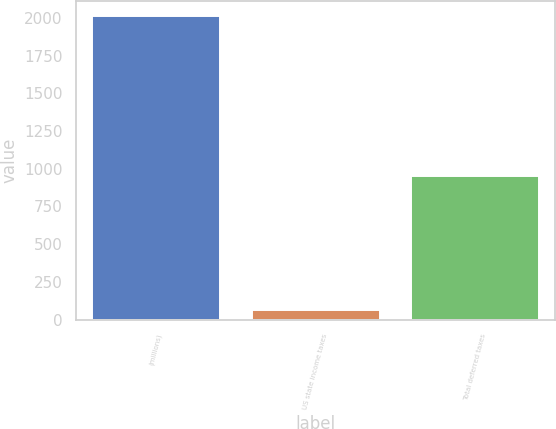<chart> <loc_0><loc_0><loc_500><loc_500><bar_chart><fcel>(millions)<fcel>US state income taxes<fcel>Total deferred taxes<nl><fcel>2012<fcel>63<fcel>950<nl></chart> 